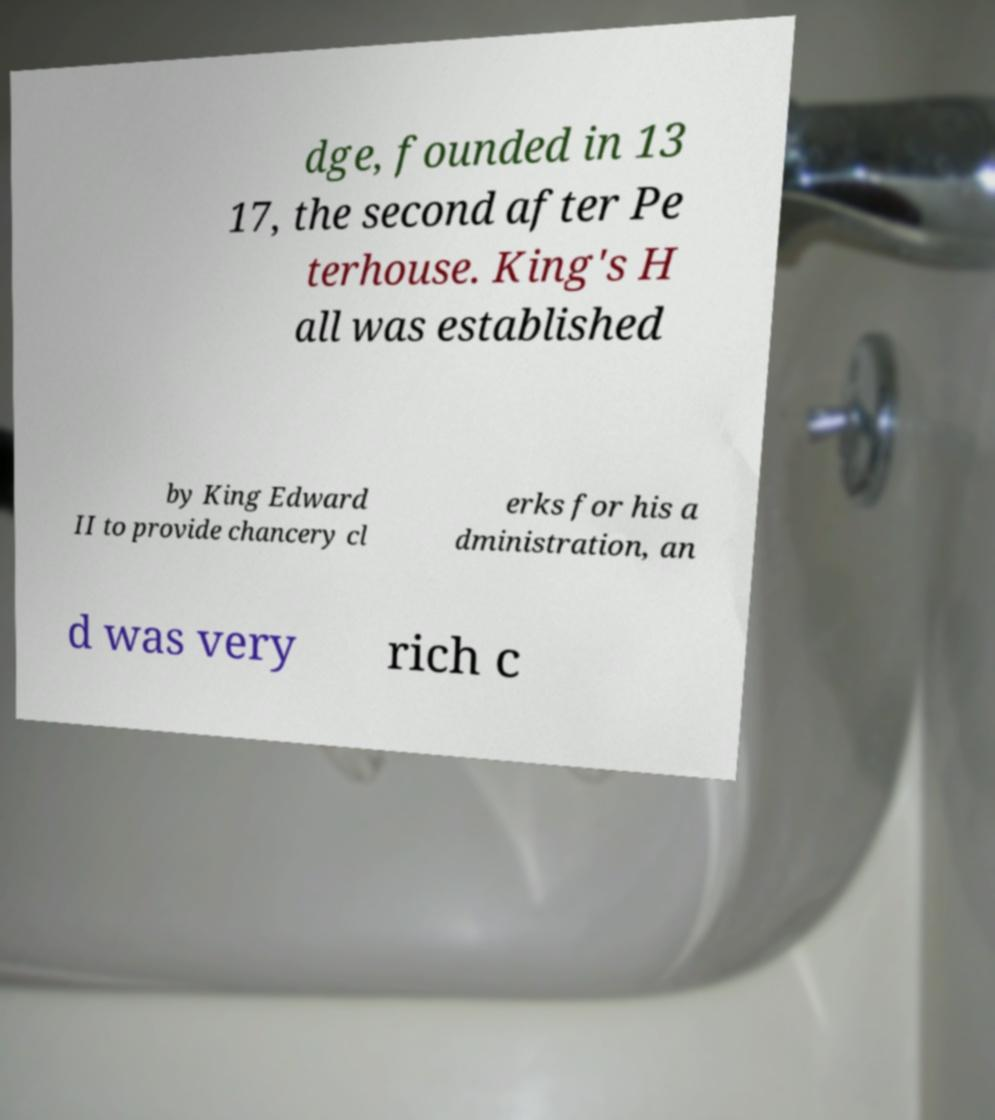There's text embedded in this image that I need extracted. Can you transcribe it verbatim? dge, founded in 13 17, the second after Pe terhouse. King's H all was established by King Edward II to provide chancery cl erks for his a dministration, an d was very rich c 